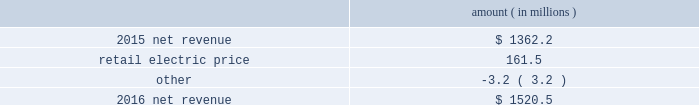Entergy arkansas , inc .
And subsidiaries management 2019s financial discussion and analysis results of operations net income 2016 compared to 2015 net income increased $ 92.9 million primarily due to higher net revenue and lower other operation and maintenance expenses , partially offset by a higher effective income tax rate and higher depreciation and amortization expenses .
2015 compared to 2014 net income decreased $ 47.1 million primarily due to higher other operation and maintenance expenses , partially offset by higher net revenue .
Net revenue 2016 compared to 2015 net revenue consists of operating revenues net of : 1 ) fuel , fuel-related expenses , and gas purchased for resale , 2 ) purchased power expenses , and 3 ) other regulatory charges ( credits ) .
Following is an analysis of the change in net revenue comparing 2016 to 2015 .
Amount ( in millions ) .
The retail electric price variance is primarily due to an increase in base rates , as approved by the apsc .
The new base rates were effective february 24 , 2016 and began billing with the first billing cycle of april 2016 .
The increase includes an interim base rate adjustment surcharge , effective with the first billing cycle of april 2016 , to recover the incremental revenue requirement for the period february 24 , 2016 through march 31 , 2016 .
A significant portion of the increase is related to the purchase of power block 2 of the union power station .
See note 2 to the financial statements for further discussion of the rate case .
See note 14 to the financial statements for further discussion of the union power station purchase. .
What was the average trailing two year net revenue amount in 2015? 
Computations: ((1520.5 + 1362.2) / 2)
Answer: 1441.35. Entergy arkansas , inc .
And subsidiaries management 2019s financial discussion and analysis results of operations net income 2016 compared to 2015 net income increased $ 92.9 million primarily due to higher net revenue and lower other operation and maintenance expenses , partially offset by a higher effective income tax rate and higher depreciation and amortization expenses .
2015 compared to 2014 net income decreased $ 47.1 million primarily due to higher other operation and maintenance expenses , partially offset by higher net revenue .
Net revenue 2016 compared to 2015 net revenue consists of operating revenues net of : 1 ) fuel , fuel-related expenses , and gas purchased for resale , 2 ) purchased power expenses , and 3 ) other regulatory charges ( credits ) .
Following is an analysis of the change in net revenue comparing 2016 to 2015 .
Amount ( in millions ) .
The retail electric price variance is primarily due to an increase in base rates , as approved by the apsc .
The new base rates were effective february 24 , 2016 and began billing with the first billing cycle of april 2016 .
The increase includes an interim base rate adjustment surcharge , effective with the first billing cycle of april 2016 , to recover the incremental revenue requirement for the period february 24 , 2016 through march 31 , 2016 .
A significant portion of the increase is related to the purchase of power block 2 of the union power station .
See note 2 to the financial statements for further discussion of the rate case .
See note 14 to the financial statements for further discussion of the union power station purchase. .
What would 2016 net revenue have been if it was impacted by the same higher other operation and maintenance expenses that impacted the prior year ( in millions ) ? 
Computations: (1520.5 - 47.1)
Answer: 1473.4. 